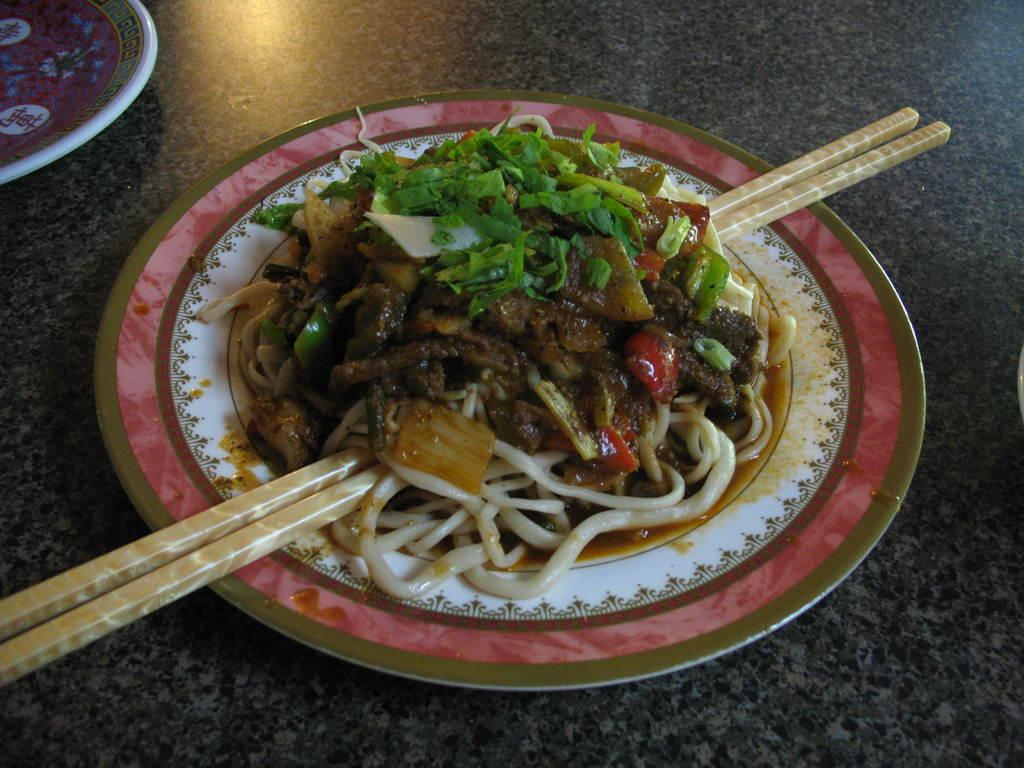What object can be seen in the image that is typically used for serving or presenting food? There is a plate in the image. What is on the plate in the image? There is food on the plate. What utensil is present in the image that is commonly used for eating certain types of food? Chopsticks are present in the image. What type of dinosaur can be seen eating the food on the plate in the image? There are no dinosaurs present in the image; it features a plate with food and chopsticks. 